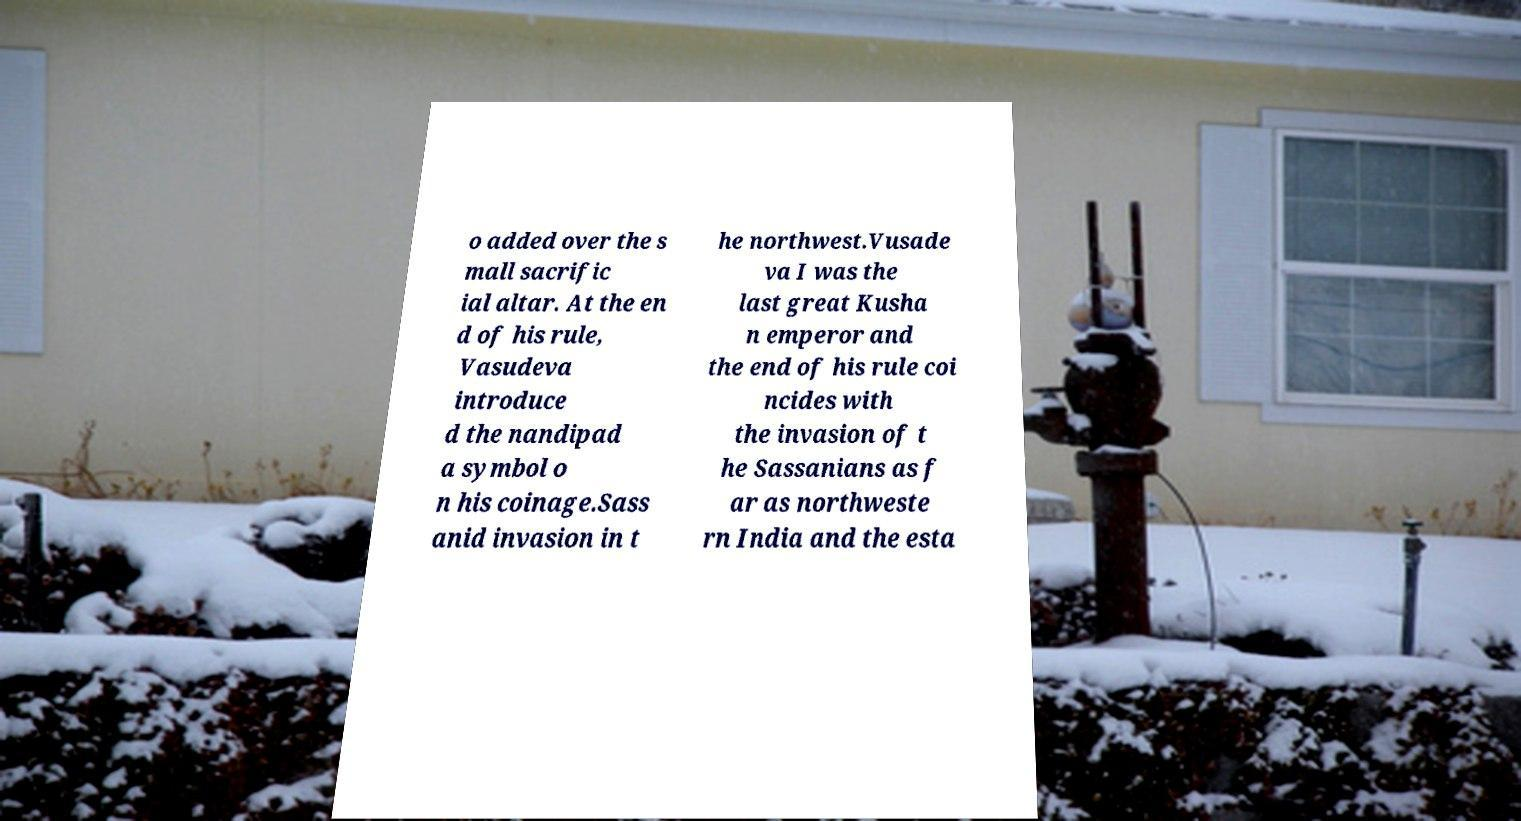Can you read and provide the text displayed in the image?This photo seems to have some interesting text. Can you extract and type it out for me? o added over the s mall sacrific ial altar. At the en d of his rule, Vasudeva introduce d the nandipad a symbol o n his coinage.Sass anid invasion in t he northwest.Vusade va I was the last great Kusha n emperor and the end of his rule coi ncides with the invasion of t he Sassanians as f ar as northweste rn India and the esta 